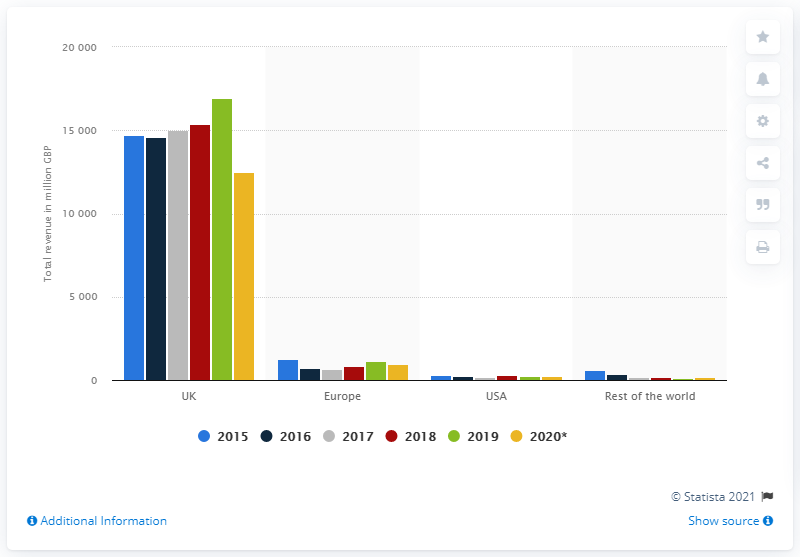Draw attention to some important aspects in this diagram. In 2020, the total revenue of NatWest in the UK was £12,511. 